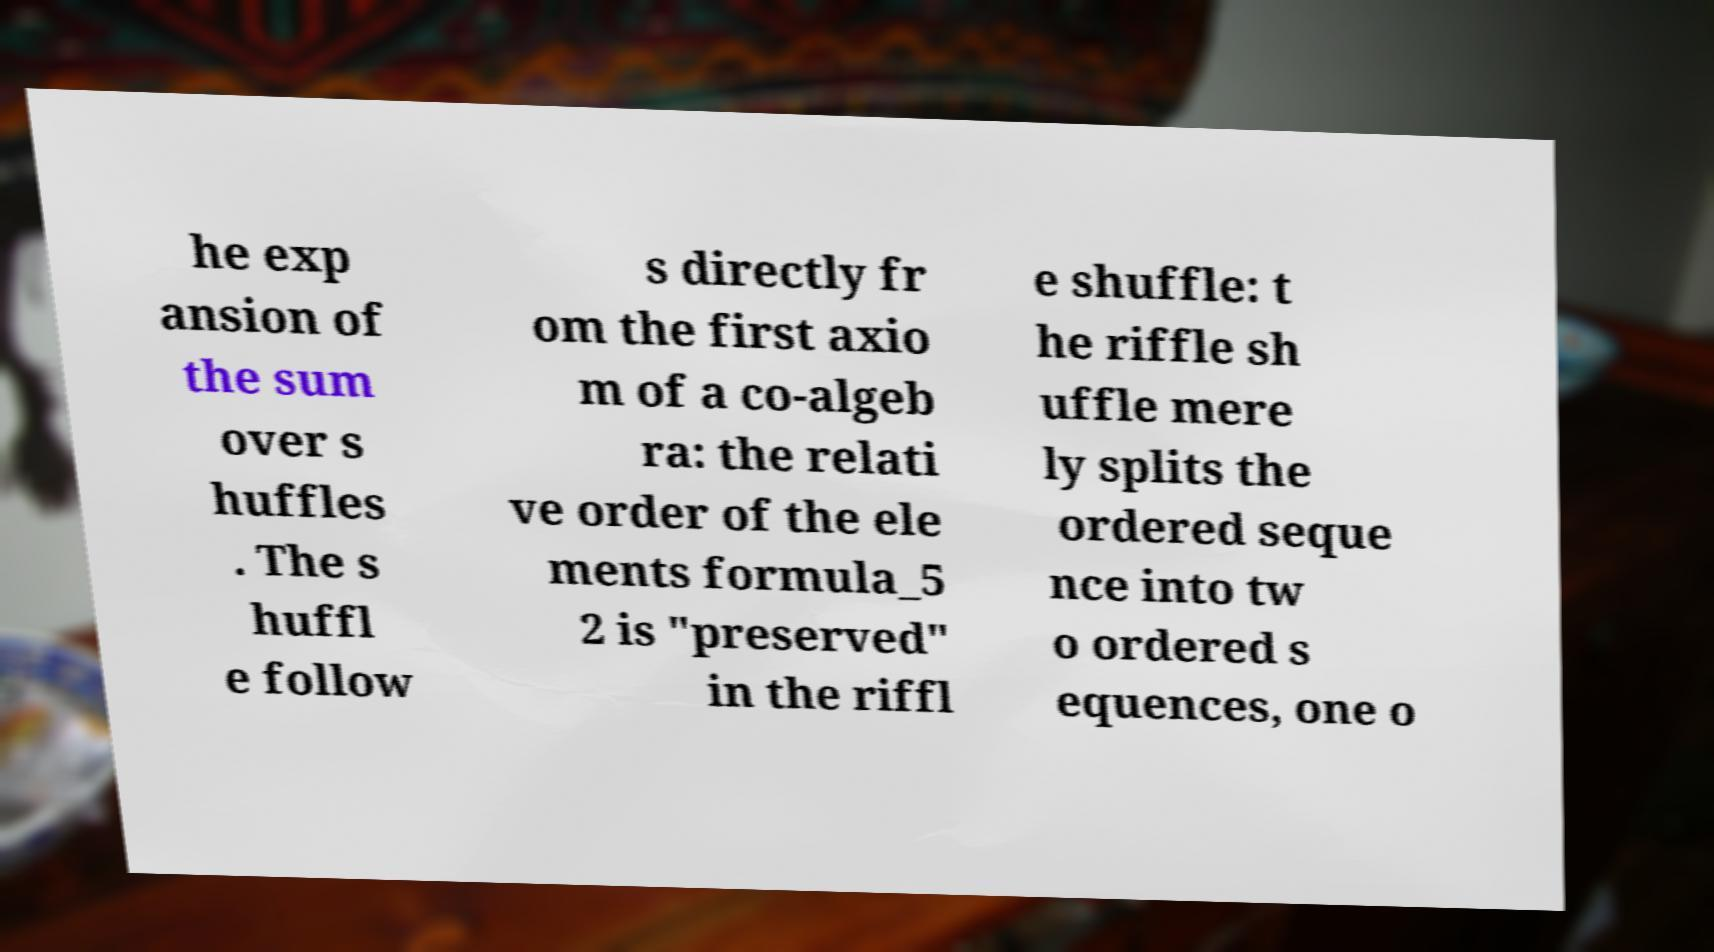Please identify and transcribe the text found in this image. he exp ansion of the sum over s huffles . The s huffl e follow s directly fr om the first axio m of a co-algeb ra: the relati ve order of the ele ments formula_5 2 is "preserved" in the riffl e shuffle: t he riffle sh uffle mere ly splits the ordered seque nce into tw o ordered s equences, one o 